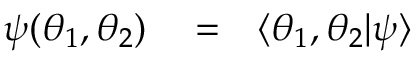<formula> <loc_0><loc_0><loc_500><loc_500>\begin{array} { r l r } { \psi ( \theta _ { 1 } , \theta _ { 2 } ) } & = } & { \langle \theta _ { 1 } , \theta _ { 2 } | \psi \rangle } \end{array}</formula> 